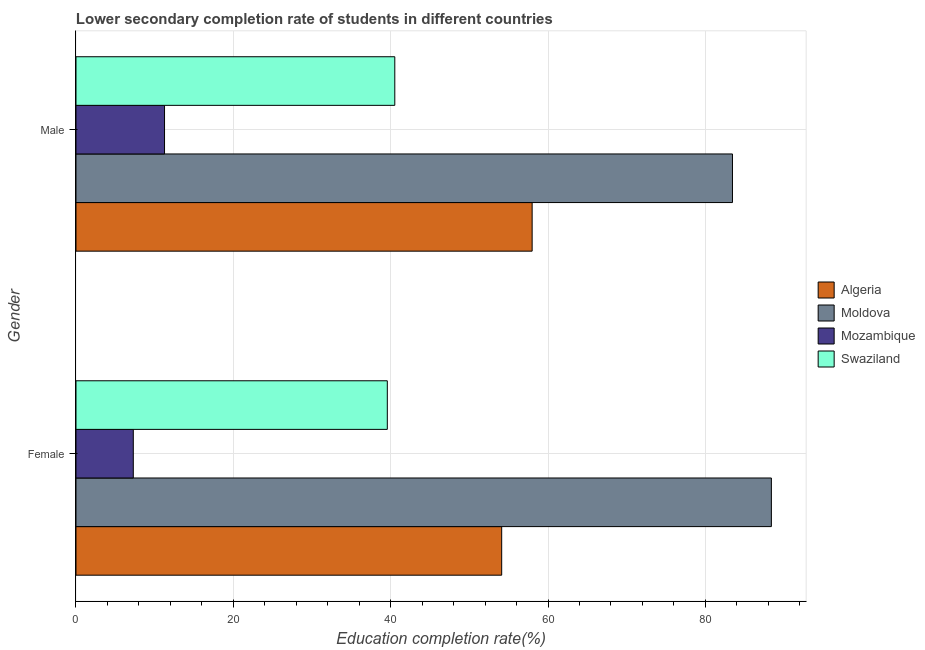Are the number of bars on each tick of the Y-axis equal?
Your answer should be compact. Yes. What is the education completion rate of male students in Swaziland?
Ensure brevity in your answer.  40.53. Across all countries, what is the maximum education completion rate of male students?
Offer a terse response. 83.45. Across all countries, what is the minimum education completion rate of male students?
Your answer should be compact. 11.26. In which country was the education completion rate of male students maximum?
Give a very brief answer. Moldova. In which country was the education completion rate of female students minimum?
Offer a terse response. Mozambique. What is the total education completion rate of male students in the graph?
Your answer should be very brief. 193.21. What is the difference between the education completion rate of female students in Swaziland and that in Moldova?
Your answer should be compact. -48.82. What is the difference between the education completion rate of female students in Algeria and the education completion rate of male students in Mozambique?
Make the answer very short. 42.86. What is the average education completion rate of male students per country?
Your answer should be compact. 48.3. What is the difference between the education completion rate of male students and education completion rate of female students in Algeria?
Offer a very short reply. 3.87. In how many countries, is the education completion rate of female students greater than 88 %?
Provide a succinct answer. 1. What is the ratio of the education completion rate of female students in Moldova to that in Swaziland?
Offer a very short reply. 2.23. Is the education completion rate of female students in Moldova less than that in Swaziland?
Offer a very short reply. No. What does the 4th bar from the top in Female represents?
Make the answer very short. Algeria. What does the 2nd bar from the bottom in Male represents?
Your answer should be compact. Moldova. How many bars are there?
Your answer should be very brief. 8. How many countries are there in the graph?
Your answer should be compact. 4. What is the difference between two consecutive major ticks on the X-axis?
Ensure brevity in your answer.  20. Are the values on the major ticks of X-axis written in scientific E-notation?
Your answer should be very brief. No. Where does the legend appear in the graph?
Offer a terse response. Center right. How many legend labels are there?
Provide a succinct answer. 4. What is the title of the graph?
Your answer should be very brief. Lower secondary completion rate of students in different countries. What is the label or title of the X-axis?
Your answer should be very brief. Education completion rate(%). What is the Education completion rate(%) of Algeria in Female?
Ensure brevity in your answer.  54.11. What is the Education completion rate(%) of Moldova in Female?
Make the answer very short. 88.39. What is the Education completion rate(%) in Mozambique in Female?
Keep it short and to the point. 7.28. What is the Education completion rate(%) in Swaziland in Female?
Offer a very short reply. 39.57. What is the Education completion rate(%) in Algeria in Male?
Provide a short and direct response. 57.98. What is the Education completion rate(%) in Moldova in Male?
Your response must be concise. 83.45. What is the Education completion rate(%) of Mozambique in Male?
Offer a very short reply. 11.26. What is the Education completion rate(%) in Swaziland in Male?
Give a very brief answer. 40.53. Across all Gender, what is the maximum Education completion rate(%) of Algeria?
Make the answer very short. 57.98. Across all Gender, what is the maximum Education completion rate(%) of Moldova?
Make the answer very short. 88.39. Across all Gender, what is the maximum Education completion rate(%) of Mozambique?
Your answer should be compact. 11.26. Across all Gender, what is the maximum Education completion rate(%) of Swaziland?
Offer a very short reply. 40.53. Across all Gender, what is the minimum Education completion rate(%) in Algeria?
Provide a short and direct response. 54.11. Across all Gender, what is the minimum Education completion rate(%) of Moldova?
Your answer should be very brief. 83.45. Across all Gender, what is the minimum Education completion rate(%) in Mozambique?
Provide a succinct answer. 7.28. Across all Gender, what is the minimum Education completion rate(%) of Swaziland?
Keep it short and to the point. 39.57. What is the total Education completion rate(%) of Algeria in the graph?
Give a very brief answer. 112.09. What is the total Education completion rate(%) of Moldova in the graph?
Provide a succinct answer. 171.84. What is the total Education completion rate(%) in Mozambique in the graph?
Your answer should be compact. 18.54. What is the total Education completion rate(%) of Swaziland in the graph?
Your answer should be very brief. 80.1. What is the difference between the Education completion rate(%) of Algeria in Female and that in Male?
Keep it short and to the point. -3.87. What is the difference between the Education completion rate(%) in Moldova in Female and that in Male?
Make the answer very short. 4.95. What is the difference between the Education completion rate(%) of Mozambique in Female and that in Male?
Provide a succinct answer. -3.97. What is the difference between the Education completion rate(%) of Swaziland in Female and that in Male?
Your answer should be compact. -0.95. What is the difference between the Education completion rate(%) in Algeria in Female and the Education completion rate(%) in Moldova in Male?
Offer a terse response. -29.34. What is the difference between the Education completion rate(%) of Algeria in Female and the Education completion rate(%) of Mozambique in Male?
Make the answer very short. 42.86. What is the difference between the Education completion rate(%) of Algeria in Female and the Education completion rate(%) of Swaziland in Male?
Give a very brief answer. 13.59. What is the difference between the Education completion rate(%) in Moldova in Female and the Education completion rate(%) in Mozambique in Male?
Provide a short and direct response. 77.14. What is the difference between the Education completion rate(%) of Moldova in Female and the Education completion rate(%) of Swaziland in Male?
Your answer should be compact. 47.87. What is the difference between the Education completion rate(%) of Mozambique in Female and the Education completion rate(%) of Swaziland in Male?
Your response must be concise. -33.24. What is the average Education completion rate(%) of Algeria per Gender?
Your answer should be compact. 56.05. What is the average Education completion rate(%) in Moldova per Gender?
Ensure brevity in your answer.  85.92. What is the average Education completion rate(%) in Mozambique per Gender?
Offer a terse response. 9.27. What is the average Education completion rate(%) of Swaziland per Gender?
Ensure brevity in your answer.  40.05. What is the difference between the Education completion rate(%) in Algeria and Education completion rate(%) in Moldova in Female?
Keep it short and to the point. -34.28. What is the difference between the Education completion rate(%) of Algeria and Education completion rate(%) of Mozambique in Female?
Keep it short and to the point. 46.83. What is the difference between the Education completion rate(%) in Algeria and Education completion rate(%) in Swaziland in Female?
Give a very brief answer. 14.54. What is the difference between the Education completion rate(%) in Moldova and Education completion rate(%) in Mozambique in Female?
Offer a terse response. 81.11. What is the difference between the Education completion rate(%) of Moldova and Education completion rate(%) of Swaziland in Female?
Keep it short and to the point. 48.82. What is the difference between the Education completion rate(%) in Mozambique and Education completion rate(%) in Swaziland in Female?
Ensure brevity in your answer.  -32.29. What is the difference between the Education completion rate(%) of Algeria and Education completion rate(%) of Moldova in Male?
Ensure brevity in your answer.  -25.47. What is the difference between the Education completion rate(%) in Algeria and Education completion rate(%) in Mozambique in Male?
Make the answer very short. 46.73. What is the difference between the Education completion rate(%) of Algeria and Education completion rate(%) of Swaziland in Male?
Make the answer very short. 17.46. What is the difference between the Education completion rate(%) in Moldova and Education completion rate(%) in Mozambique in Male?
Ensure brevity in your answer.  72.19. What is the difference between the Education completion rate(%) of Moldova and Education completion rate(%) of Swaziland in Male?
Provide a short and direct response. 42.92. What is the difference between the Education completion rate(%) in Mozambique and Education completion rate(%) in Swaziland in Male?
Ensure brevity in your answer.  -29.27. What is the ratio of the Education completion rate(%) of Algeria in Female to that in Male?
Your answer should be compact. 0.93. What is the ratio of the Education completion rate(%) of Moldova in Female to that in Male?
Your answer should be very brief. 1.06. What is the ratio of the Education completion rate(%) of Mozambique in Female to that in Male?
Give a very brief answer. 0.65. What is the ratio of the Education completion rate(%) in Swaziland in Female to that in Male?
Offer a terse response. 0.98. What is the difference between the highest and the second highest Education completion rate(%) of Algeria?
Provide a short and direct response. 3.87. What is the difference between the highest and the second highest Education completion rate(%) in Moldova?
Make the answer very short. 4.95. What is the difference between the highest and the second highest Education completion rate(%) in Mozambique?
Your response must be concise. 3.97. What is the difference between the highest and the second highest Education completion rate(%) of Swaziland?
Your answer should be compact. 0.95. What is the difference between the highest and the lowest Education completion rate(%) of Algeria?
Your answer should be very brief. 3.87. What is the difference between the highest and the lowest Education completion rate(%) in Moldova?
Provide a short and direct response. 4.95. What is the difference between the highest and the lowest Education completion rate(%) in Mozambique?
Your answer should be very brief. 3.97. What is the difference between the highest and the lowest Education completion rate(%) of Swaziland?
Offer a terse response. 0.95. 